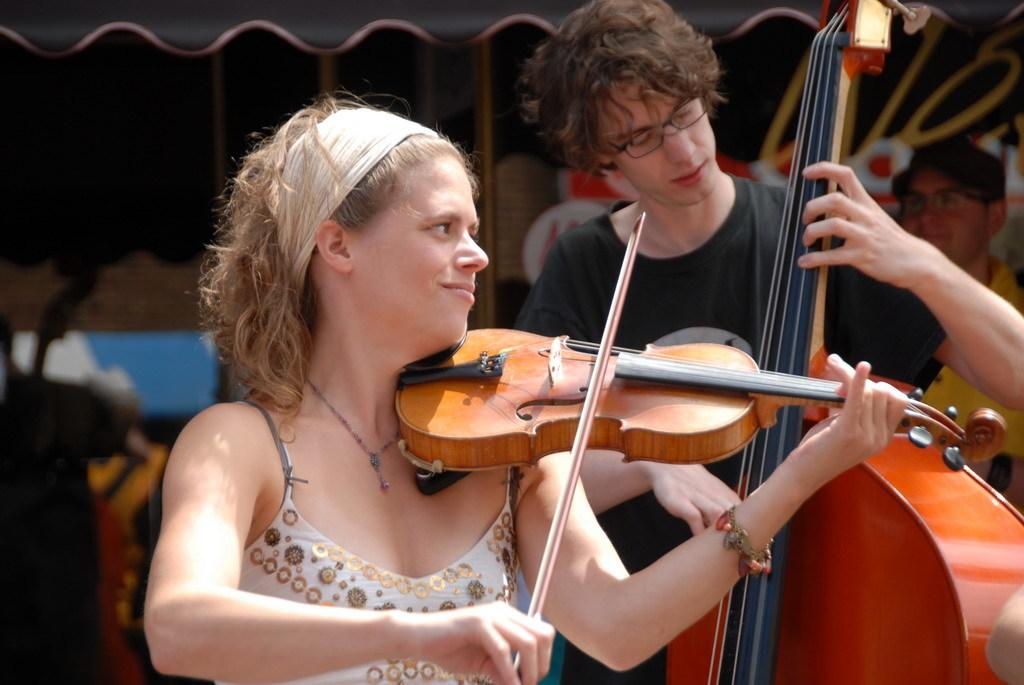How many people are in the image? There are two people in the image, a girl and a boy. What are the girl and the boy holding in the image? The girl is holding a musical instrument, and the boy is also holding a musical instrument. What is the reaction of the zebra to the musical instruments in the image? There is no zebra present in the image, so it is not possible to determine its reaction to the musical instruments. 